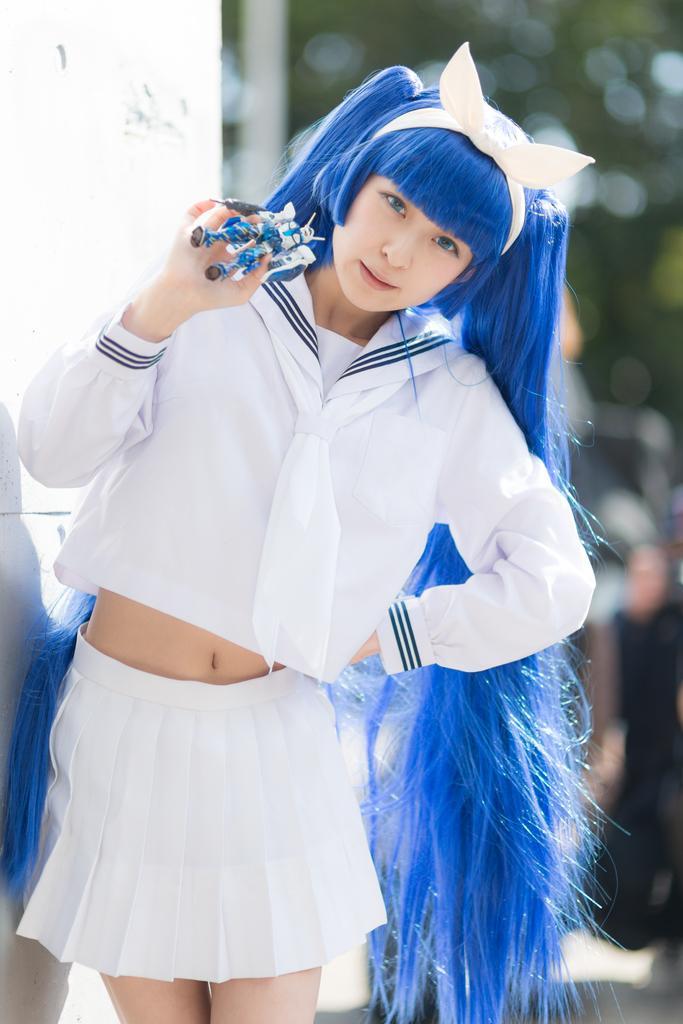In one or two sentences, can you explain what this image depicts? In this picture there is a woman standing and holding a toy and we can see wall. In the background of the image it is blurry. 